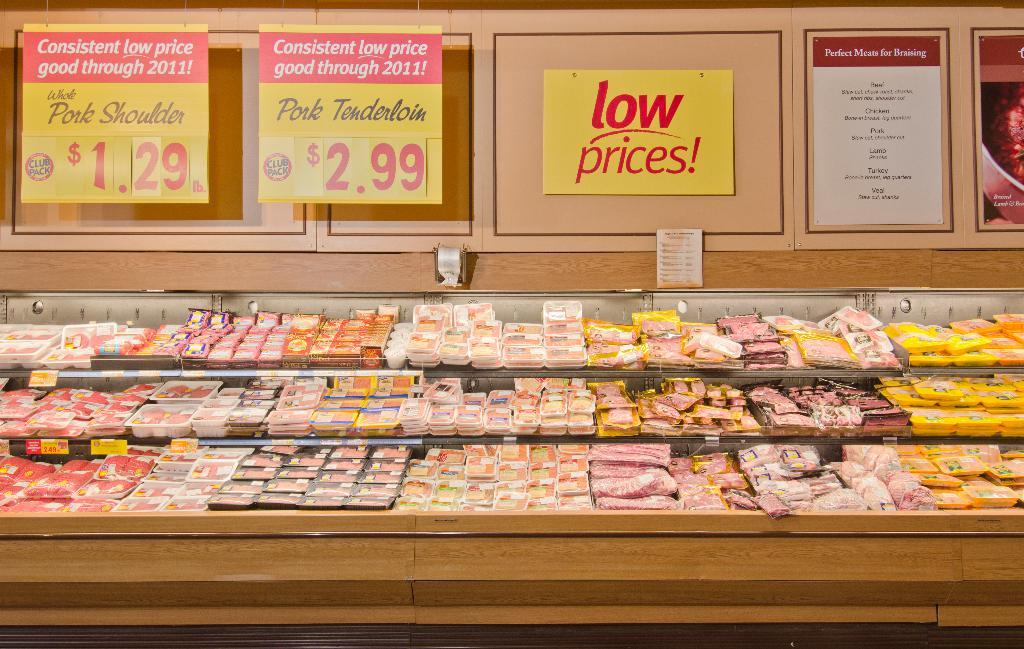How much are pork shoulders?
Make the answer very short. $1.29 lb. 